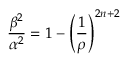<formula> <loc_0><loc_0><loc_500><loc_500>\frac { \beta ^ { 2 } } { \alpha ^ { 2 } } = 1 - \left ( \frac { 1 } { \rho } \right ) ^ { 2 n + 2 }</formula> 